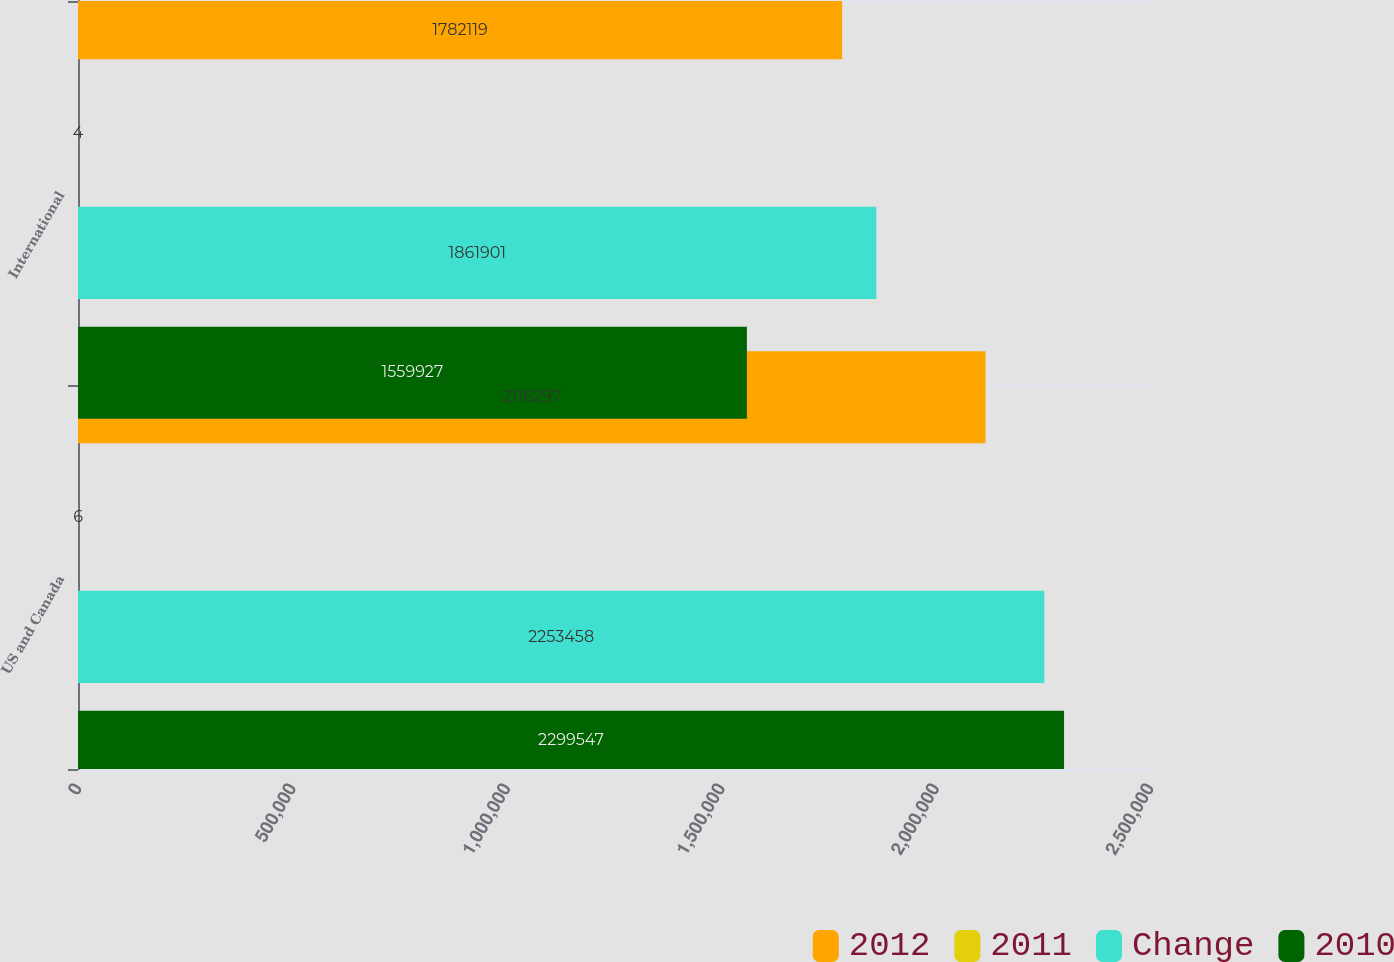Convert chart to OTSL. <chart><loc_0><loc_0><loc_500><loc_500><stacked_bar_chart><ecel><fcel>US and Canada<fcel>International<nl><fcel>2012<fcel>2.1163e+06<fcel>1.78212e+06<nl><fcel>2011<fcel>6<fcel>4<nl><fcel>Change<fcel>2.25346e+06<fcel>1.8619e+06<nl><fcel>2010<fcel>2.29955e+06<fcel>1.55993e+06<nl></chart> 